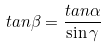<formula> <loc_0><loc_0><loc_500><loc_500>t a n \beta = \frac { t a n \alpha } { \sin \gamma }</formula> 